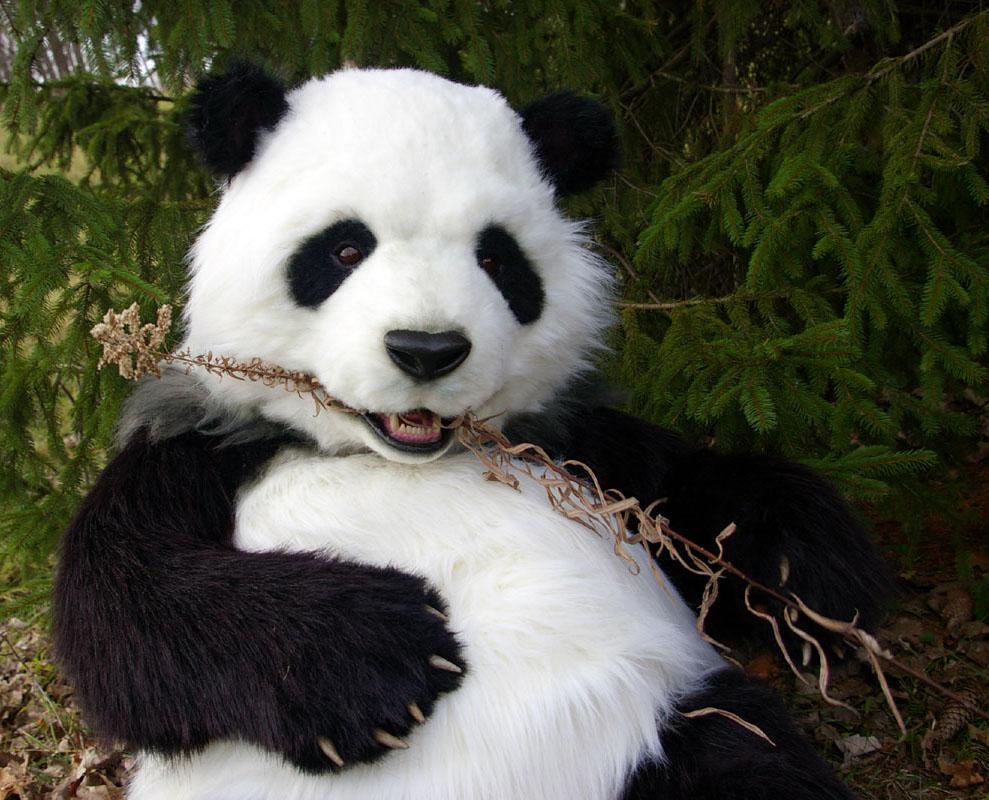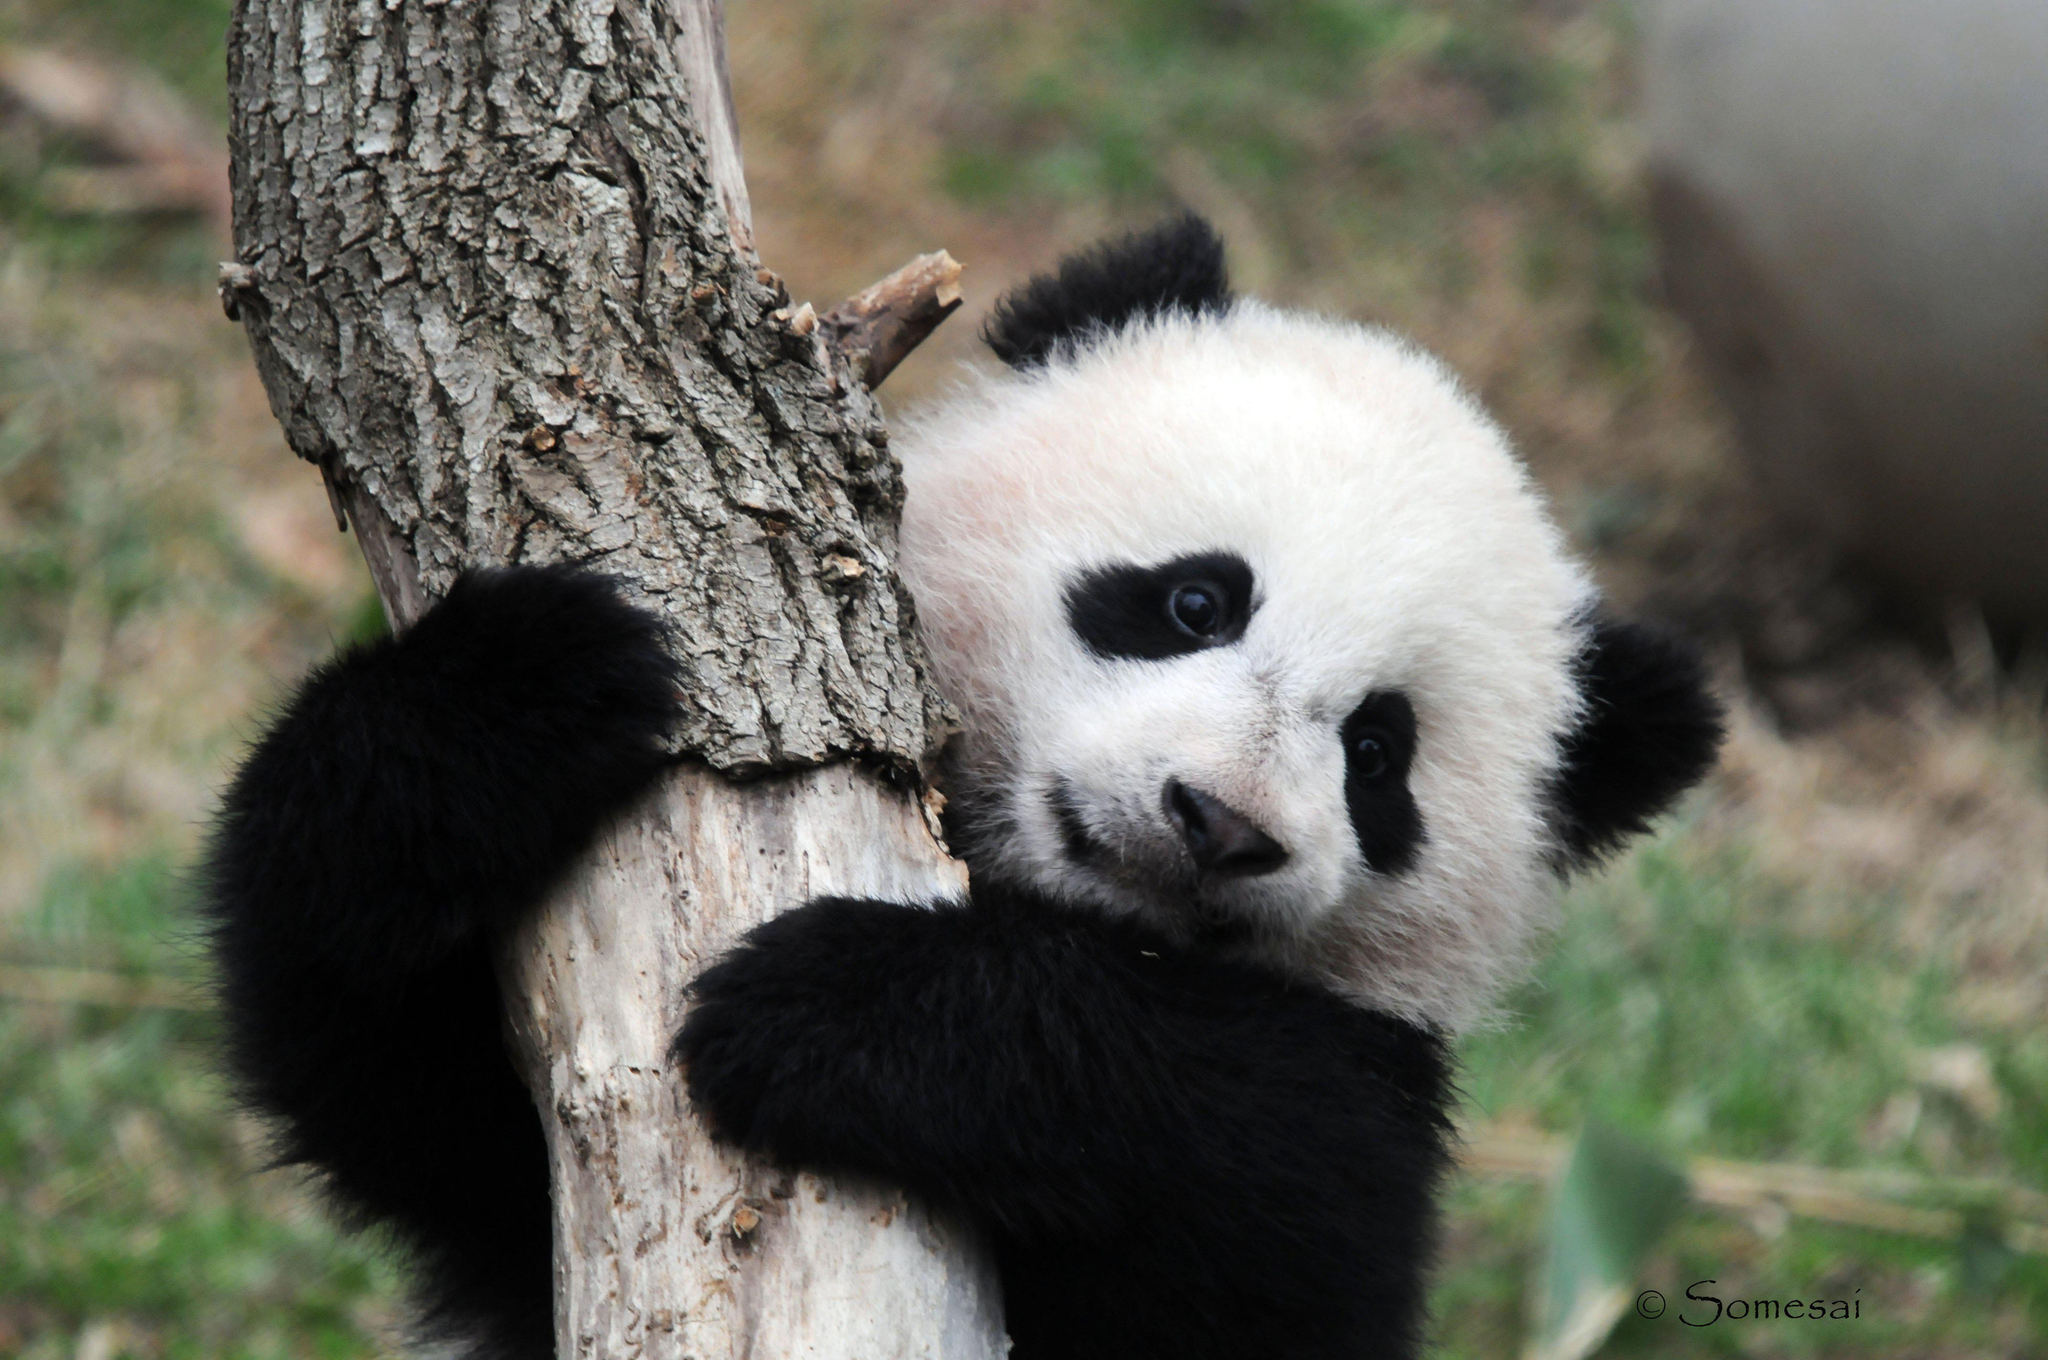The first image is the image on the left, the second image is the image on the right. Given the left and right images, does the statement "A panda is hanging on a branch" hold true? Answer yes or no. Yes. 